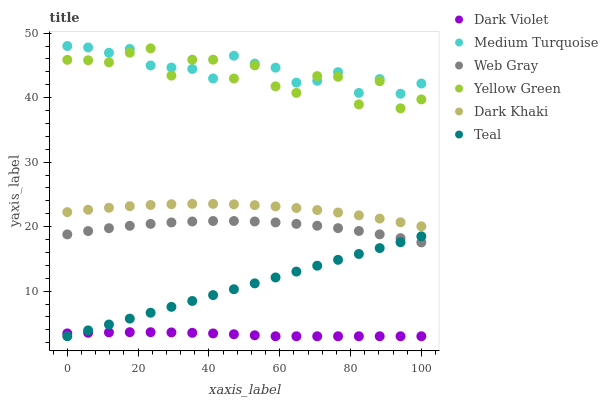Does Dark Violet have the minimum area under the curve?
Answer yes or no. Yes. Does Medium Turquoise have the maximum area under the curve?
Answer yes or no. Yes. Does Medium Turquoise have the minimum area under the curve?
Answer yes or no. No. Does Dark Violet have the maximum area under the curve?
Answer yes or no. No. Is Teal the smoothest?
Answer yes or no. Yes. Is Yellow Green the roughest?
Answer yes or no. Yes. Is Medium Turquoise the smoothest?
Answer yes or no. No. Is Medium Turquoise the roughest?
Answer yes or no. No. Does Dark Violet have the lowest value?
Answer yes or no. Yes. Does Medium Turquoise have the lowest value?
Answer yes or no. No. Does Medium Turquoise have the highest value?
Answer yes or no. Yes. Does Dark Violet have the highest value?
Answer yes or no. No. Is Web Gray less than Dark Khaki?
Answer yes or no. Yes. Is Medium Turquoise greater than Dark Khaki?
Answer yes or no. Yes. Does Medium Turquoise intersect Yellow Green?
Answer yes or no. Yes. Is Medium Turquoise less than Yellow Green?
Answer yes or no. No. Is Medium Turquoise greater than Yellow Green?
Answer yes or no. No. Does Web Gray intersect Dark Khaki?
Answer yes or no. No. 